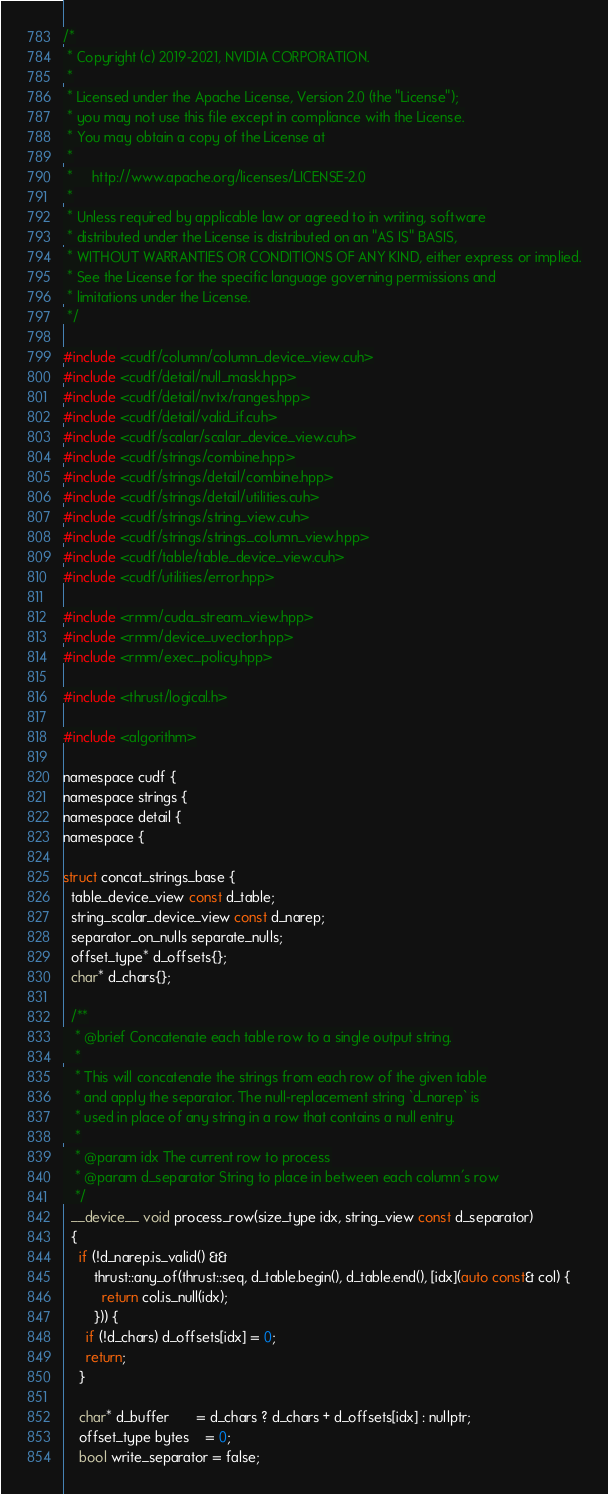Convert code to text. <code><loc_0><loc_0><loc_500><loc_500><_Cuda_>/*
 * Copyright (c) 2019-2021, NVIDIA CORPORATION.
 *
 * Licensed under the Apache License, Version 2.0 (the "License");
 * you may not use this file except in compliance with the License.
 * You may obtain a copy of the License at
 *
 *     http://www.apache.org/licenses/LICENSE-2.0
 *
 * Unless required by applicable law or agreed to in writing, software
 * distributed under the License is distributed on an "AS IS" BASIS,
 * WITHOUT WARRANTIES OR CONDITIONS OF ANY KIND, either express or implied.
 * See the License for the specific language governing permissions and
 * limitations under the License.
 */

#include <cudf/column/column_device_view.cuh>
#include <cudf/detail/null_mask.hpp>
#include <cudf/detail/nvtx/ranges.hpp>
#include <cudf/detail/valid_if.cuh>
#include <cudf/scalar/scalar_device_view.cuh>
#include <cudf/strings/combine.hpp>
#include <cudf/strings/detail/combine.hpp>
#include <cudf/strings/detail/utilities.cuh>
#include <cudf/strings/string_view.cuh>
#include <cudf/strings/strings_column_view.hpp>
#include <cudf/table/table_device_view.cuh>
#include <cudf/utilities/error.hpp>

#include <rmm/cuda_stream_view.hpp>
#include <rmm/device_uvector.hpp>
#include <rmm/exec_policy.hpp>

#include <thrust/logical.h>

#include <algorithm>

namespace cudf {
namespace strings {
namespace detail {
namespace {

struct concat_strings_base {
  table_device_view const d_table;
  string_scalar_device_view const d_narep;
  separator_on_nulls separate_nulls;
  offset_type* d_offsets{};
  char* d_chars{};

  /**
   * @brief Concatenate each table row to a single output string.
   *
   * This will concatenate the strings from each row of the given table
   * and apply the separator. The null-replacement string `d_narep` is
   * used in place of any string in a row that contains a null entry.
   *
   * @param idx The current row to process
   * @param d_separator String to place in between each column's row
   */
  __device__ void process_row(size_type idx, string_view const d_separator)
  {
    if (!d_narep.is_valid() &&
        thrust::any_of(thrust::seq, d_table.begin(), d_table.end(), [idx](auto const& col) {
          return col.is_null(idx);
        })) {
      if (!d_chars) d_offsets[idx] = 0;
      return;
    }

    char* d_buffer       = d_chars ? d_chars + d_offsets[idx] : nullptr;
    offset_type bytes    = 0;
    bool write_separator = false;
</code> 